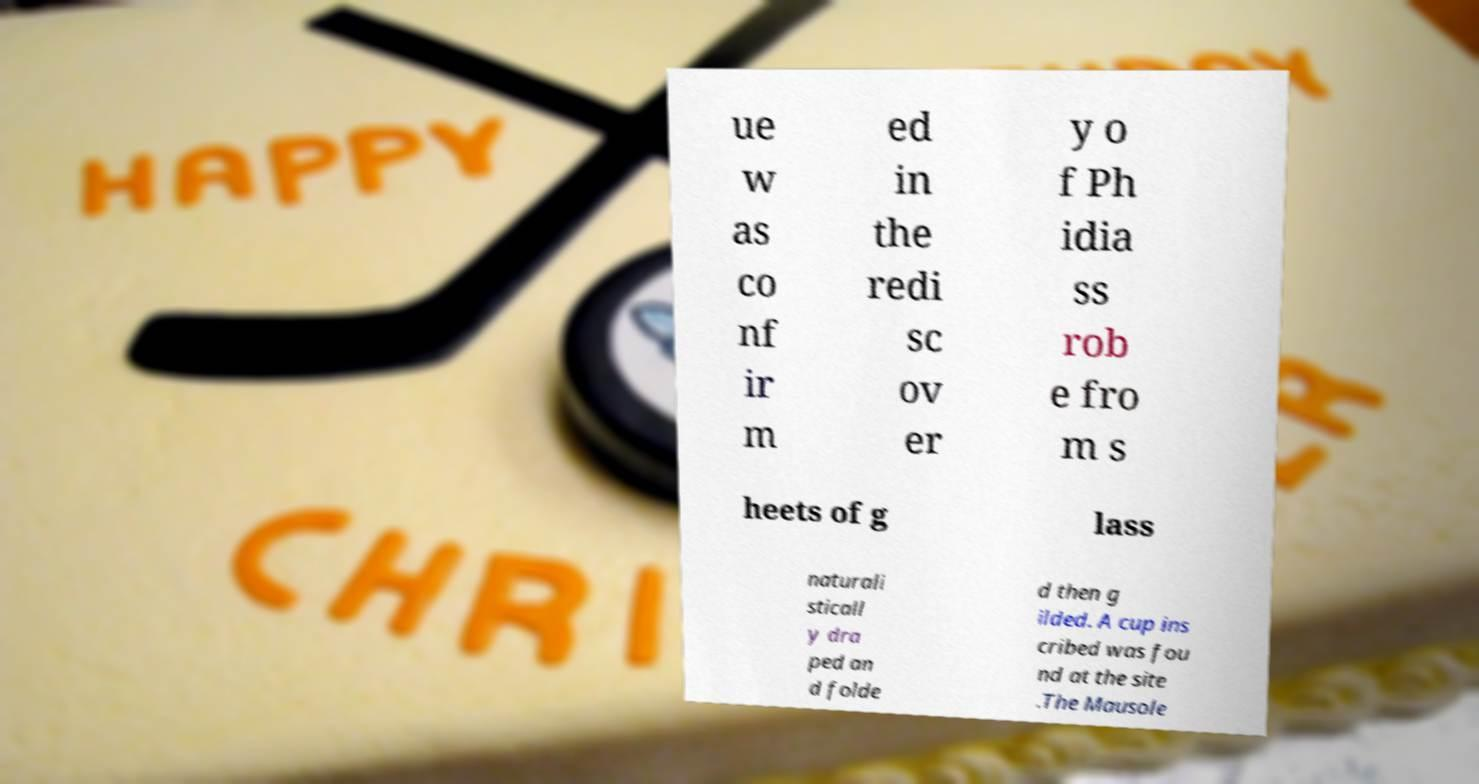What messages or text are displayed in this image? I need them in a readable, typed format. ue w as co nf ir m ed in the redi sc ov er y o f Ph idia ss rob e fro m s heets of g lass naturali sticall y dra ped an d folde d then g ilded. A cup ins cribed was fou nd at the site .The Mausole 